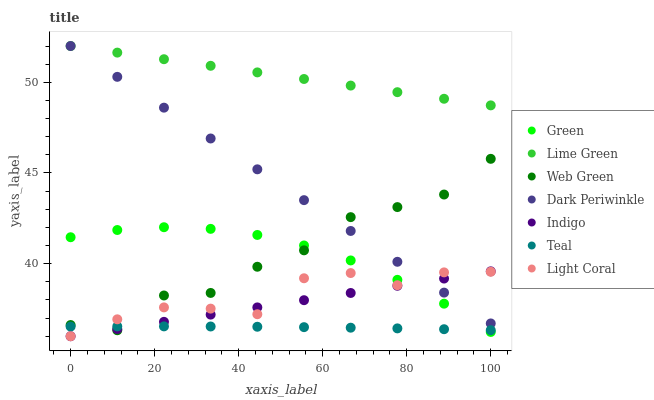Does Teal have the minimum area under the curve?
Answer yes or no. Yes. Does Lime Green have the maximum area under the curve?
Answer yes or no. Yes. Does Web Green have the minimum area under the curve?
Answer yes or no. No. Does Web Green have the maximum area under the curve?
Answer yes or no. No. Is Dark Periwinkle the smoothest?
Answer yes or no. Yes. Is Web Green the roughest?
Answer yes or no. Yes. Is Light Coral the smoothest?
Answer yes or no. No. Is Light Coral the roughest?
Answer yes or no. No. Does Indigo have the lowest value?
Answer yes or no. Yes. Does Web Green have the lowest value?
Answer yes or no. No. Does Dark Periwinkle have the highest value?
Answer yes or no. Yes. Does Web Green have the highest value?
Answer yes or no. No. Is Indigo less than Lime Green?
Answer yes or no. Yes. Is Lime Green greater than Web Green?
Answer yes or no. Yes. Does Indigo intersect Green?
Answer yes or no. Yes. Is Indigo less than Green?
Answer yes or no. No. Is Indigo greater than Green?
Answer yes or no. No. Does Indigo intersect Lime Green?
Answer yes or no. No. 